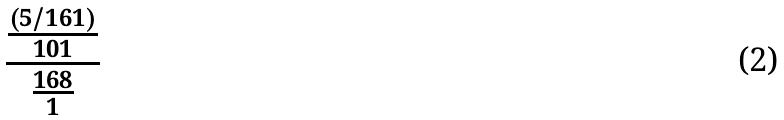<formula> <loc_0><loc_0><loc_500><loc_500>\frac { \frac { ( 5 / 1 6 1 ) } { 1 0 1 } } { \frac { 1 6 8 } { 1 } }</formula> 